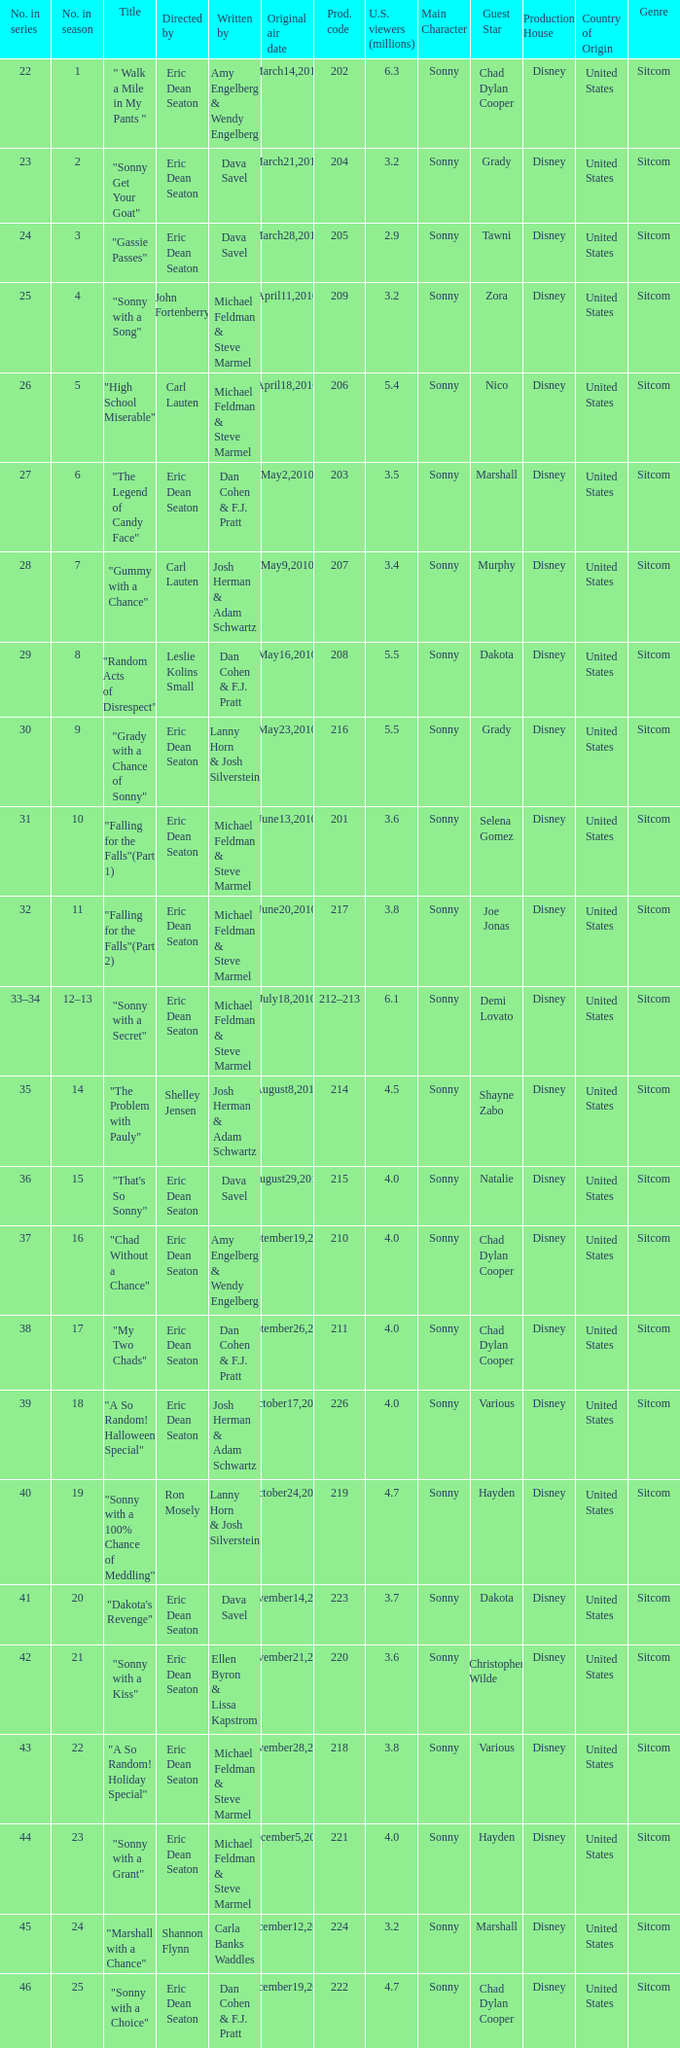Who directed the episode that 6.3 million u.s. viewers saw? Eric Dean Seaton. 